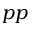<formula> <loc_0><loc_0><loc_500><loc_500>p p</formula> 